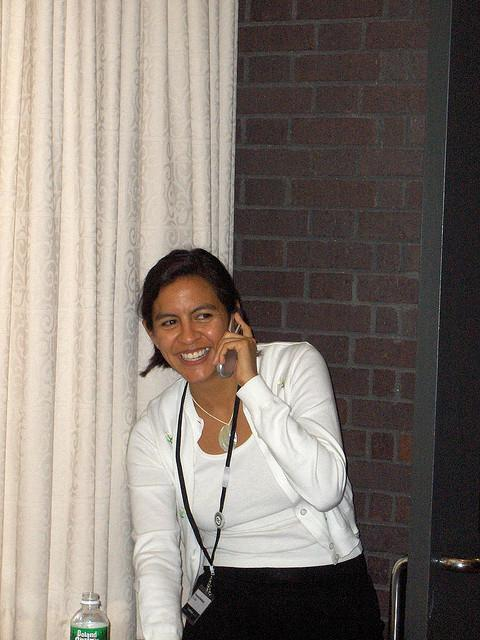How is she communicating? Please explain your reasoning. phone. She's has the cellular device up to her ear which means someone is talking on the other line. 